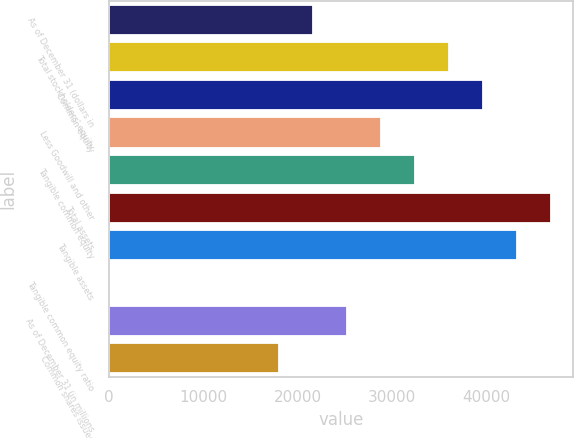Convert chart. <chart><loc_0><loc_0><loc_500><loc_500><bar_chart><fcel>As of December 31 (dollars in<fcel>Total stockholders' equity<fcel>Common equity<fcel>Less Goodwill and other<fcel>Tangible common equity<fcel>Total assets<fcel>Tangible assets<fcel>Tangible common equity ratio<fcel>As of December 31 (in millions<fcel>Common shares issued<nl><fcel>21616.2<fcel>36022<fcel>39623.4<fcel>28819.1<fcel>32420.5<fcel>46826.3<fcel>43224.9<fcel>7.5<fcel>25217.7<fcel>18014.8<nl></chart> 